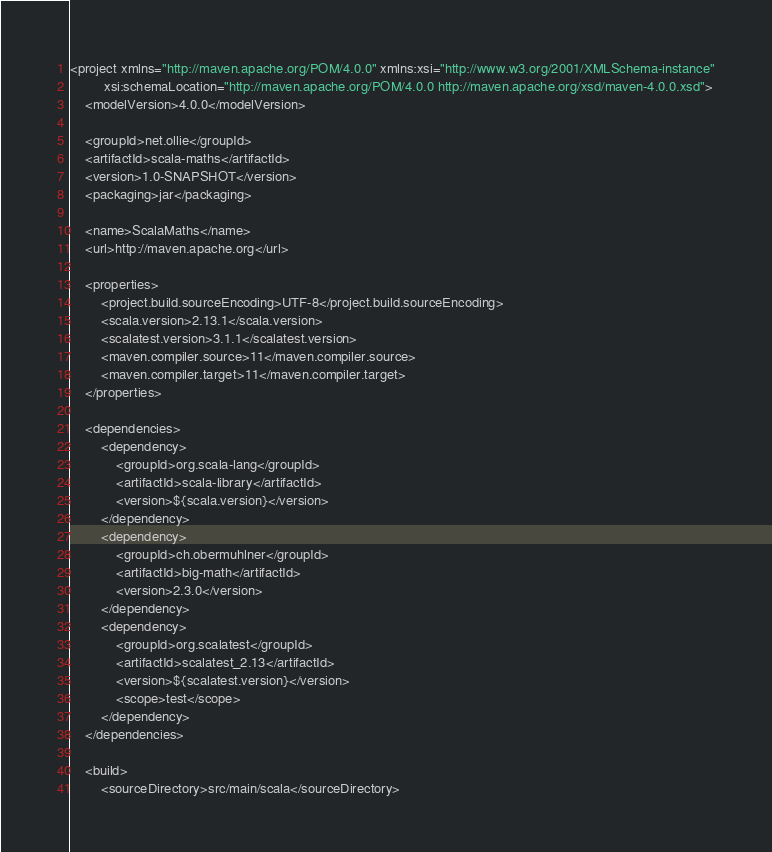<code> <loc_0><loc_0><loc_500><loc_500><_XML_><project xmlns="http://maven.apache.org/POM/4.0.0" xmlns:xsi="http://www.w3.org/2001/XMLSchema-instance"
         xsi:schemaLocation="http://maven.apache.org/POM/4.0.0 http://maven.apache.org/xsd/maven-4.0.0.xsd">
    <modelVersion>4.0.0</modelVersion>

    <groupId>net.ollie</groupId>
    <artifactId>scala-maths</artifactId>
    <version>1.0-SNAPSHOT</version>
    <packaging>jar</packaging>

    <name>ScalaMaths</name>
    <url>http://maven.apache.org</url>

    <properties>
        <project.build.sourceEncoding>UTF-8</project.build.sourceEncoding>
        <scala.version>2.13.1</scala.version>
        <scalatest.version>3.1.1</scalatest.version>
        <maven.compiler.source>11</maven.compiler.source>
        <maven.compiler.target>11</maven.compiler.target>
    </properties>

    <dependencies>
        <dependency>
            <groupId>org.scala-lang</groupId>
            <artifactId>scala-library</artifactId>
            <version>${scala.version}</version>
        </dependency>
        <dependency>
            <groupId>ch.obermuhlner</groupId>
            <artifactId>big-math</artifactId>
            <version>2.3.0</version>
        </dependency>
        <dependency>
            <groupId>org.scalatest</groupId>
            <artifactId>scalatest_2.13</artifactId>
            <version>${scalatest.version}</version>
            <scope>test</scope>
        </dependency>
    </dependencies>

    <build>
        <sourceDirectory>src/main/scala</sourceDirectory></code> 